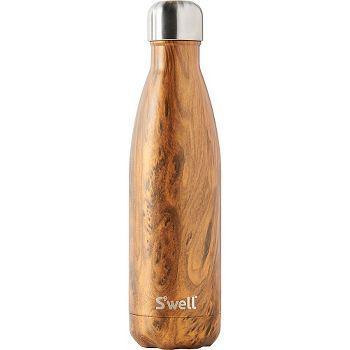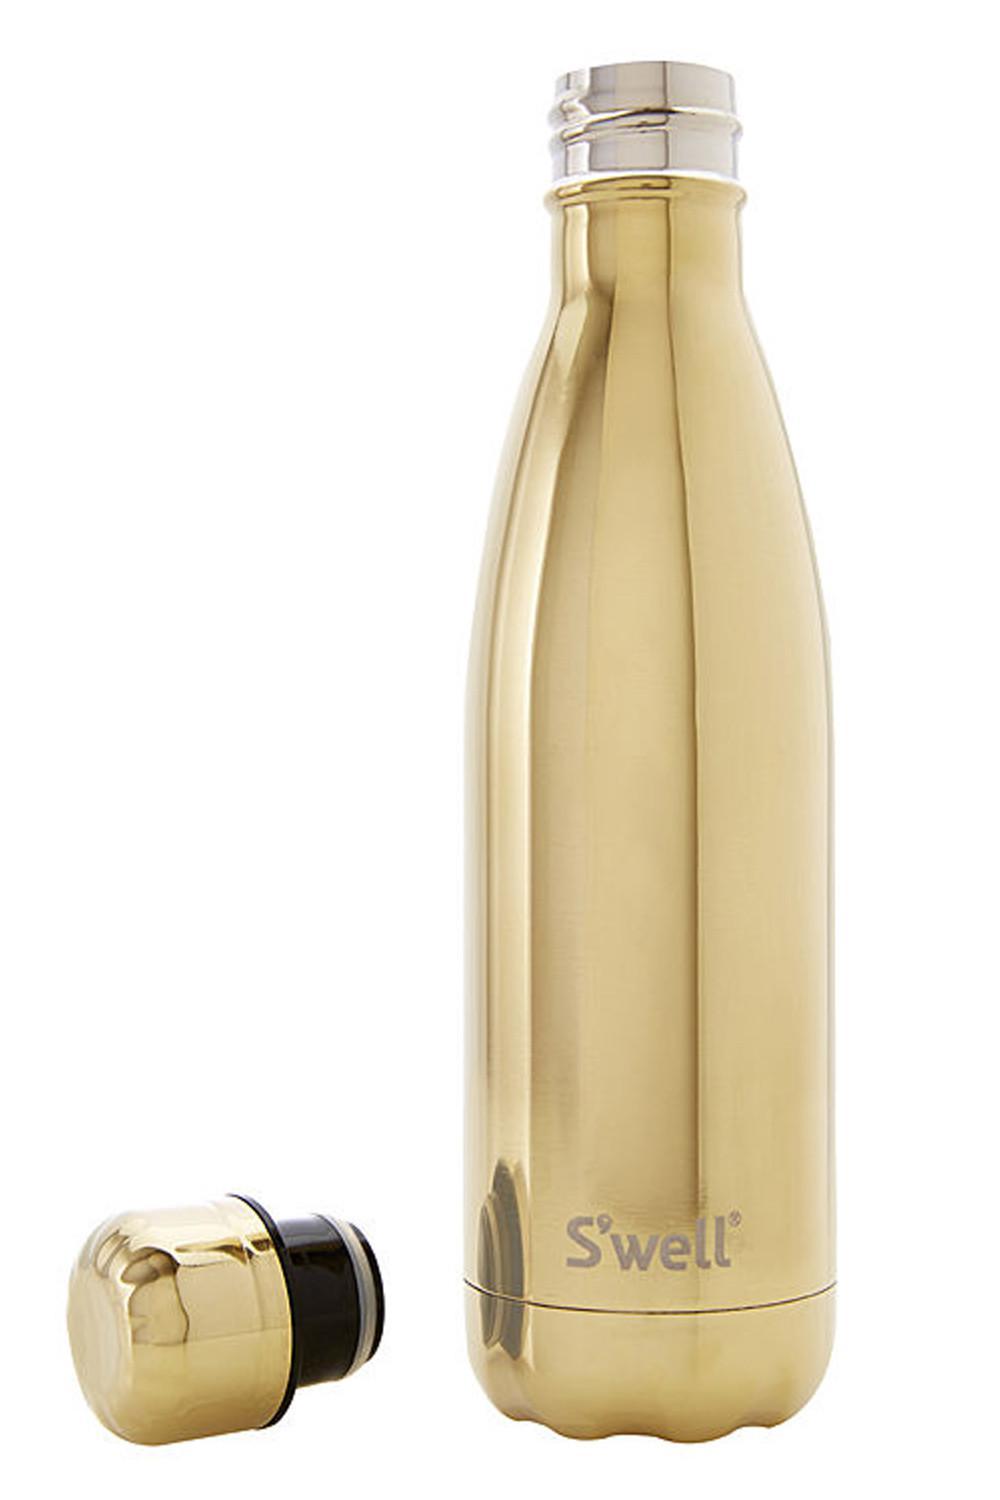The first image is the image on the left, the second image is the image on the right. For the images shown, is this caption "the bottle on the left image has a wooden look" true? Answer yes or no. Yes. 